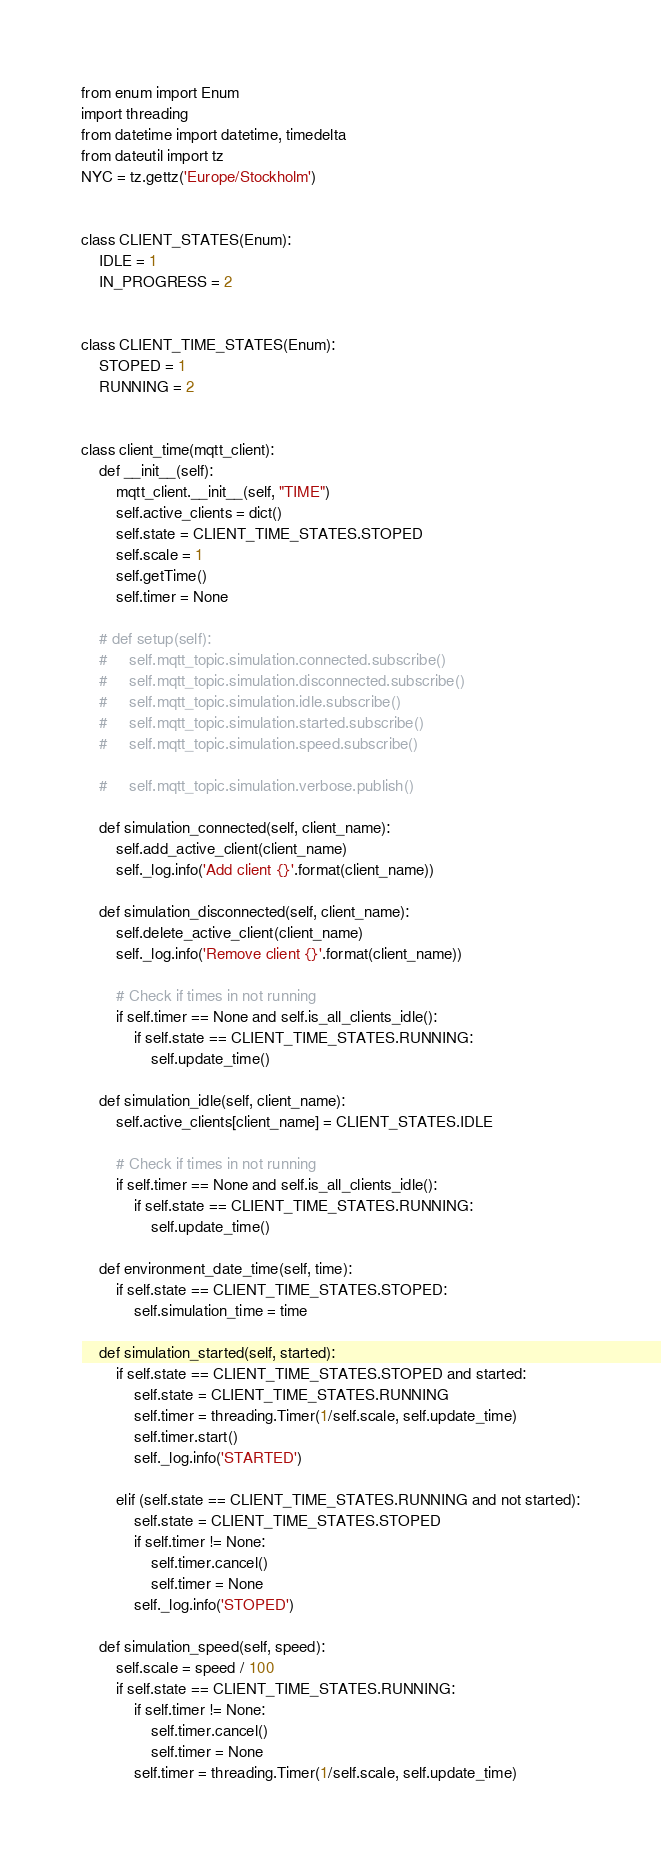<code> <loc_0><loc_0><loc_500><loc_500><_Python_>from enum import Enum
import threading
from datetime import datetime, timedelta
from dateutil import tz
NYC = tz.gettz('Europe/Stockholm')


class CLIENT_STATES(Enum):
    IDLE = 1
    IN_PROGRESS = 2


class CLIENT_TIME_STATES(Enum):
    STOPED = 1
    RUNNING = 2


class client_time(mqtt_client):
    def __init__(self):
        mqtt_client.__init__(self, "TIME")
        self.active_clients = dict()
        self.state = CLIENT_TIME_STATES.STOPED
        self.scale = 1
        self.getTime()
        self.timer = None

    # def setup(self):
    #     self.mqtt_topic.simulation.connected.subscribe()
    #     self.mqtt_topic.simulation.disconnected.subscribe()
    #     self.mqtt_topic.simulation.idle.subscribe()
    #     self.mqtt_topic.simulation.started.subscribe()
    #     self.mqtt_topic.simulation.speed.subscribe()

    #     self.mqtt_topic.simulation.verbose.publish()

    def simulation_connected(self, client_name):
        self.add_active_client(client_name)
        self._log.info('Add client {}'.format(client_name))

    def simulation_disconnected(self, client_name):
        self.delete_active_client(client_name)
        self._log.info('Remove client {}'.format(client_name))

        # Check if times in not running
        if self.timer == None and self.is_all_clients_idle():
            if self.state == CLIENT_TIME_STATES.RUNNING:
                self.update_time()

    def simulation_idle(self, client_name):
        self.active_clients[client_name] = CLIENT_STATES.IDLE

        # Check if times in not running
        if self.timer == None and self.is_all_clients_idle():
            if self.state == CLIENT_TIME_STATES.RUNNING:
                self.update_time()

    def environment_date_time(self, time):
        if self.state == CLIENT_TIME_STATES.STOPED:
            self.simulation_time = time

    def simulation_started(self, started):
        if self.state == CLIENT_TIME_STATES.STOPED and started:
            self.state = CLIENT_TIME_STATES.RUNNING
            self.timer = threading.Timer(1/self.scale, self.update_time)
            self.timer.start()
            self._log.info('STARTED')

        elif (self.state == CLIENT_TIME_STATES.RUNNING and not started):
            self.state = CLIENT_TIME_STATES.STOPED
            if self.timer != None:
                self.timer.cancel()
                self.timer = None
            self._log.info('STOPED')

    def simulation_speed(self, speed):
        self.scale = speed / 100
        if self.state == CLIENT_TIME_STATES.RUNNING:
            if self.timer != None:
                self.timer.cancel()
                self.timer = None
            self.timer = threading.Timer(1/self.scale, self.update_time)</code> 